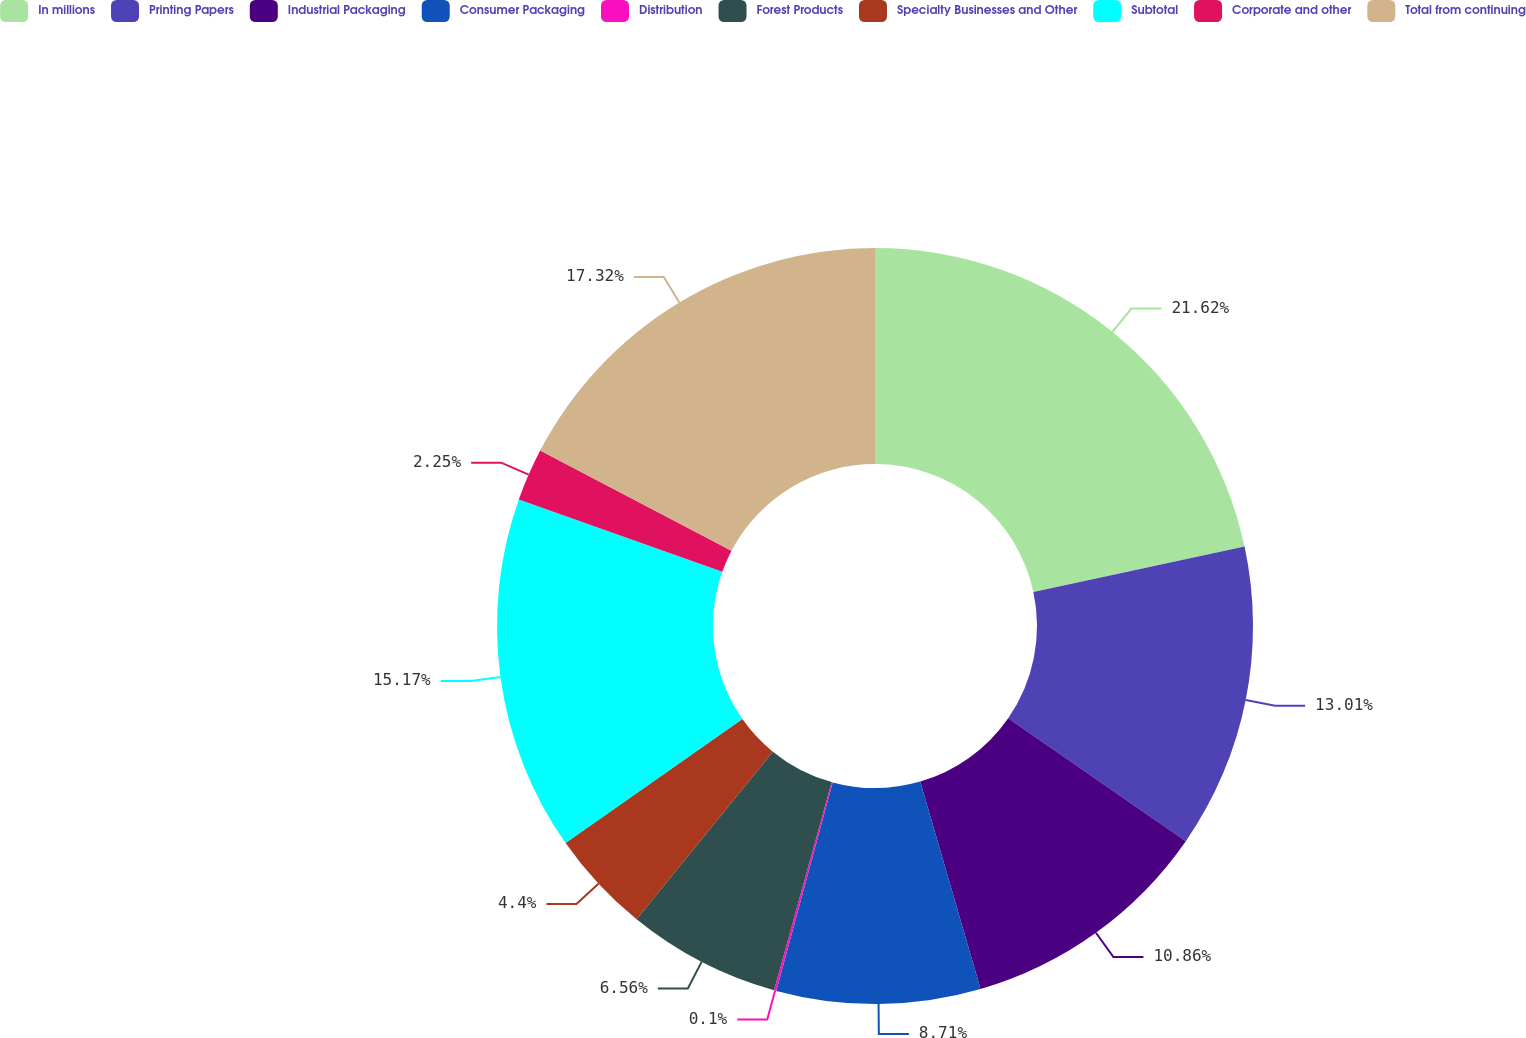<chart> <loc_0><loc_0><loc_500><loc_500><pie_chart><fcel>In millions<fcel>Printing Papers<fcel>Industrial Packaging<fcel>Consumer Packaging<fcel>Distribution<fcel>Forest Products<fcel>Specialty Businesses and Other<fcel>Subtotal<fcel>Corporate and other<fcel>Total from continuing<nl><fcel>21.63%<fcel>13.01%<fcel>10.86%<fcel>8.71%<fcel>0.1%<fcel>6.56%<fcel>4.4%<fcel>15.17%<fcel>2.25%<fcel>17.32%<nl></chart> 